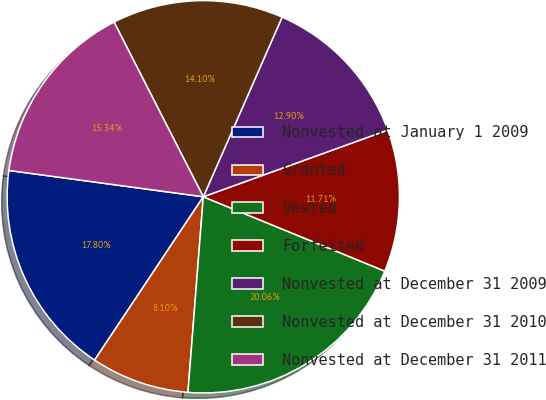Convert chart to OTSL. <chart><loc_0><loc_0><loc_500><loc_500><pie_chart><fcel>Nonvested at January 1 2009<fcel>Granted<fcel>Vested<fcel>Forfeited<fcel>Nonvested at December 31 2009<fcel>Nonvested at December 31 2010<fcel>Nonvested at December 31 2011<nl><fcel>17.8%<fcel>8.1%<fcel>20.06%<fcel>11.71%<fcel>12.9%<fcel>14.1%<fcel>15.34%<nl></chart> 